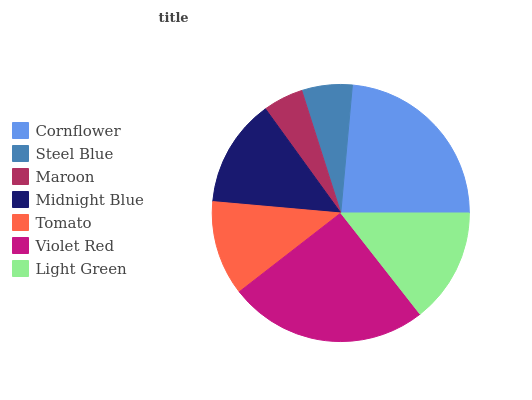Is Maroon the minimum?
Answer yes or no. Yes. Is Violet Red the maximum?
Answer yes or no. Yes. Is Steel Blue the minimum?
Answer yes or no. No. Is Steel Blue the maximum?
Answer yes or no. No. Is Cornflower greater than Steel Blue?
Answer yes or no. Yes. Is Steel Blue less than Cornflower?
Answer yes or no. Yes. Is Steel Blue greater than Cornflower?
Answer yes or no. No. Is Cornflower less than Steel Blue?
Answer yes or no. No. Is Midnight Blue the high median?
Answer yes or no. Yes. Is Midnight Blue the low median?
Answer yes or no. Yes. Is Steel Blue the high median?
Answer yes or no. No. Is Tomato the low median?
Answer yes or no. No. 